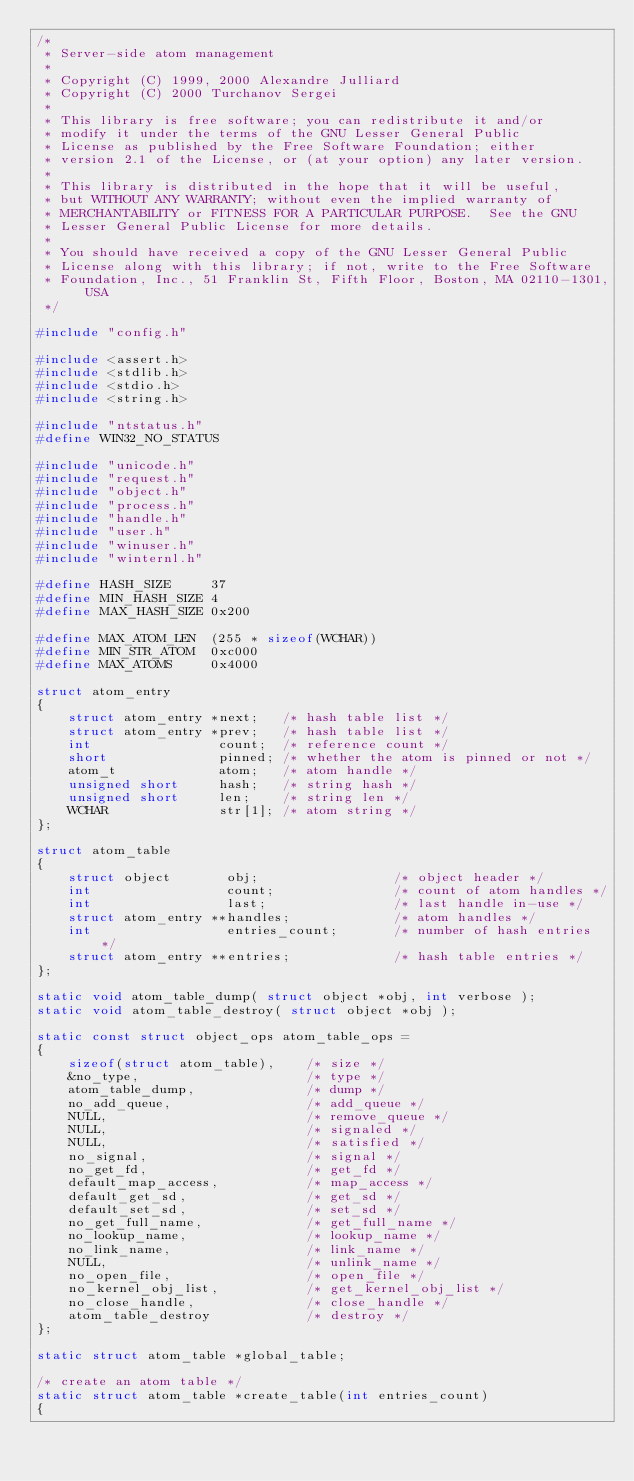Convert code to text. <code><loc_0><loc_0><loc_500><loc_500><_C_>/*
 * Server-side atom management
 *
 * Copyright (C) 1999, 2000 Alexandre Julliard
 * Copyright (C) 2000 Turchanov Sergei
 *
 * This library is free software; you can redistribute it and/or
 * modify it under the terms of the GNU Lesser General Public
 * License as published by the Free Software Foundation; either
 * version 2.1 of the License, or (at your option) any later version.
 *
 * This library is distributed in the hope that it will be useful,
 * but WITHOUT ANY WARRANTY; without even the implied warranty of
 * MERCHANTABILITY or FITNESS FOR A PARTICULAR PURPOSE.  See the GNU
 * Lesser General Public License for more details.
 *
 * You should have received a copy of the GNU Lesser General Public
 * License along with this library; if not, write to the Free Software
 * Foundation, Inc., 51 Franklin St, Fifth Floor, Boston, MA 02110-1301, USA
 */

#include "config.h"

#include <assert.h>
#include <stdlib.h>
#include <stdio.h>
#include <string.h>

#include "ntstatus.h"
#define WIN32_NO_STATUS

#include "unicode.h"
#include "request.h"
#include "object.h"
#include "process.h"
#include "handle.h"
#include "user.h"
#include "winuser.h"
#include "winternl.h"

#define HASH_SIZE     37
#define MIN_HASH_SIZE 4
#define MAX_HASH_SIZE 0x200

#define MAX_ATOM_LEN  (255 * sizeof(WCHAR))
#define MIN_STR_ATOM  0xc000
#define MAX_ATOMS     0x4000

struct atom_entry
{
    struct atom_entry *next;   /* hash table list */
    struct atom_entry *prev;   /* hash table list */
    int                count;  /* reference count */
    short              pinned; /* whether the atom is pinned or not */
    atom_t             atom;   /* atom handle */
    unsigned short     hash;   /* string hash */
    unsigned short     len;    /* string len */
    WCHAR              str[1]; /* atom string */
};

struct atom_table
{
    struct object       obj;                 /* object header */
    int                 count;               /* count of atom handles */
    int                 last;                /* last handle in-use */
    struct atom_entry **handles;             /* atom handles */
    int                 entries_count;       /* number of hash entries */
    struct atom_entry **entries;             /* hash table entries */
};

static void atom_table_dump( struct object *obj, int verbose );
static void atom_table_destroy( struct object *obj );

static const struct object_ops atom_table_ops =
{
    sizeof(struct atom_table),    /* size */
    &no_type,                     /* type */
    atom_table_dump,              /* dump */
    no_add_queue,                 /* add_queue */
    NULL,                         /* remove_queue */
    NULL,                         /* signaled */
    NULL,                         /* satisfied */
    no_signal,                    /* signal */
    no_get_fd,                    /* get_fd */
    default_map_access,           /* map_access */
    default_get_sd,               /* get_sd */
    default_set_sd,               /* set_sd */
    no_get_full_name,             /* get_full_name */
    no_lookup_name,               /* lookup_name */
    no_link_name,                 /* link_name */
    NULL,                         /* unlink_name */
    no_open_file,                 /* open_file */
    no_kernel_obj_list,           /* get_kernel_obj_list */
    no_close_handle,              /* close_handle */
    atom_table_destroy            /* destroy */
};

static struct atom_table *global_table;

/* create an atom table */
static struct atom_table *create_table(int entries_count)
{</code> 